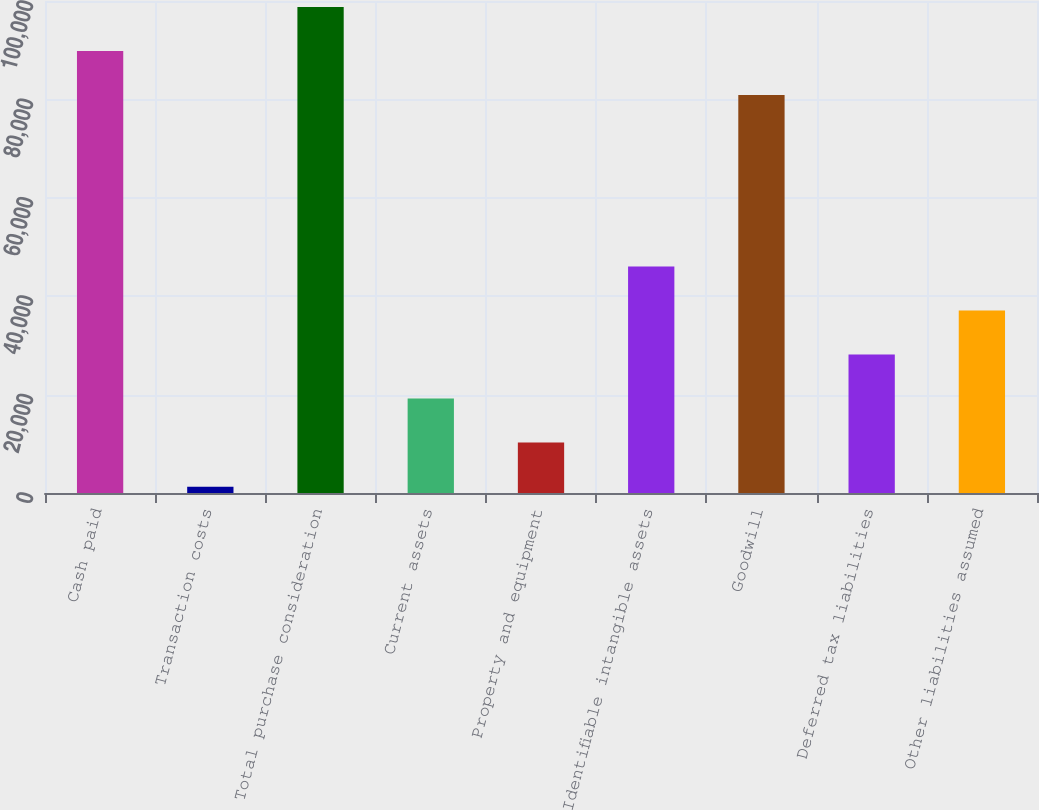<chart> <loc_0><loc_0><loc_500><loc_500><bar_chart><fcel>Cash paid<fcel>Transaction costs<fcel>Total purchase consideration<fcel>Current assets<fcel>Property and equipment<fcel>Identifiable intangible assets<fcel>Goodwill<fcel>Deferred tax liabilities<fcel>Other liabilities assumed<nl><fcel>89853<fcel>1294<fcel>98805<fcel>19198<fcel>10246<fcel>46054<fcel>80901<fcel>28150<fcel>37102<nl></chart> 